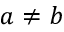<formula> <loc_0><loc_0><loc_500><loc_500>a \neq b</formula> 